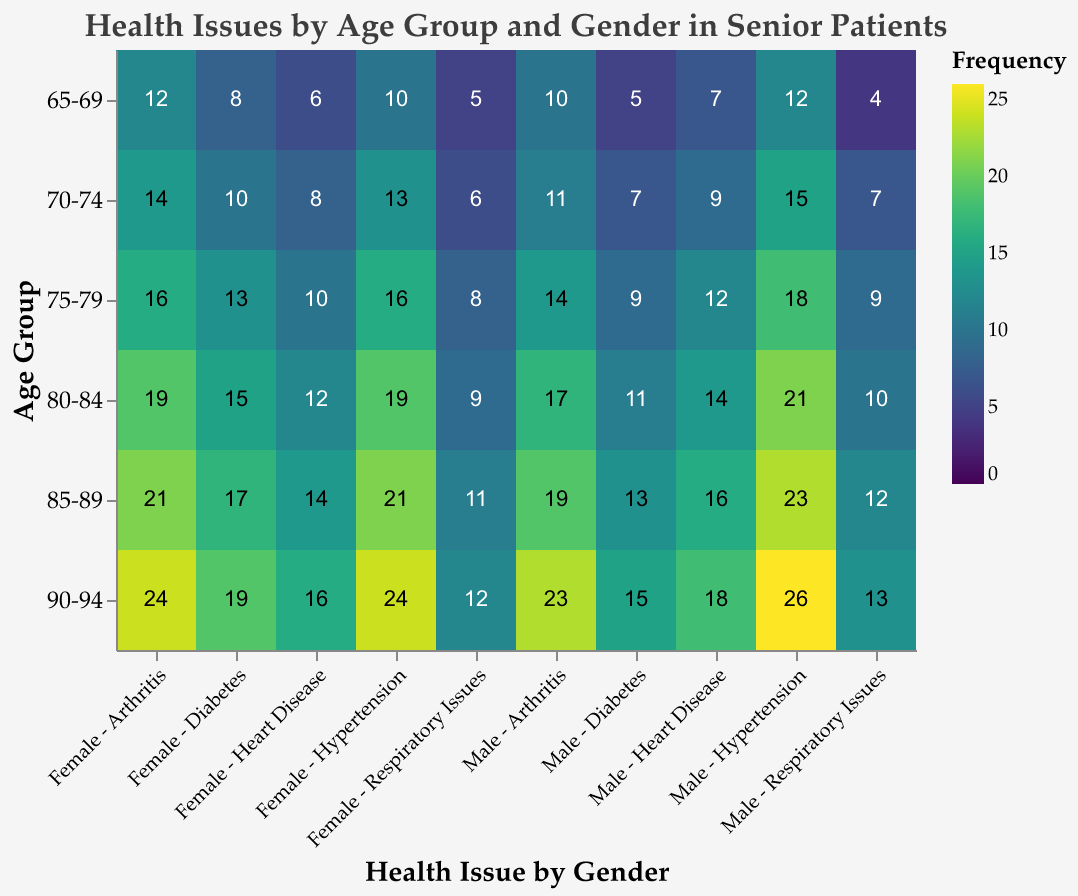What is the most frequent health issue for males aged 90-94? Locate the age group "90-94" and the gender "Male" on the x and y axes, respectively, then find the highest value among the health issues. The highest value is for "Hypertension" with a frequency of 26.
Answer: Hypertension Which gender has a higher occurrence of diabetes in the 70-74 age group? Find the "70-74" age group and compare the diabetes values for males (7) and females (10).
Answer: Female What is the second most common health issue among females aged 85-89? For the age group "85-89" and gender "Female," list the values for each health issue: Heart Disease (14), Diabetes (17), Hypertension (21), Arthritis (21), Respiratory Issues (11). The second highest values are for Heart Disease (14) and Respiratory Issues (11), making Heart Disease the single highest among them.
Answer: Heart Disease How does the frequency of respiratory issues change with age for females? Track the values for "Respiratory Issues" across all age groups for females: 65-69 (5), 70-74 (6), 75-79 (8), 80-84 (9), 85-89 (11), 90-94 (12). Notice the steady increase in values with age.
Answer: Increases Do males aged 75-79 have more hypertensive cases than those aged 70-74? Compare "Hypertension" values for males in age groups 75-79 (18) and 70-74 (15). 18 is greater than 15.
Answer: Yes Which age group has the highest frequency of arthritis in males? Look at the "Arthritis" values for males across all age groups: 65-69 (10), 70-74 (11), 75-79 (14), 80-84 (17), 85-89 (19), 90-94 (23). The highest value is for the age group 90-94 (23).
Answer: 90-94 What is the average frequency of heart disease in females aged 80-84 and 90-94? Heart Disease for females aged 80-84 is 12 and for 90-94 is 16. Calculate the average as (12 + 16) / 2 = 14.
Answer: 14 Compare the total frequency of diabetes and hypertension in males aged 85-89. Which is higher? For males aged 85-89, Diabetes is 13 and Hypertension is 23. Comparing the two values, Hypertension (23) is higher.
Answer: Hypertension How many total respiratory issues do females aged 65-69 and 85-89 have? Sum the "Respiratory Issues" values for females in age groups 65-69 (5) and 85-89 (11). The total is 5 + 11 = 16.
Answer: 16 Is arthritis more common in older age groups compared to younger age groups for both genders? Compare the progression of "Arthritis" values starting from the youngest age group (65-69) to the oldest (90-94) for both males and females. For males: 10, 11, 14, 17, 19, 23 and for females: 12, 14, 16, 19, 21, 24. Both show an increasing trend.
Answer: Yes 